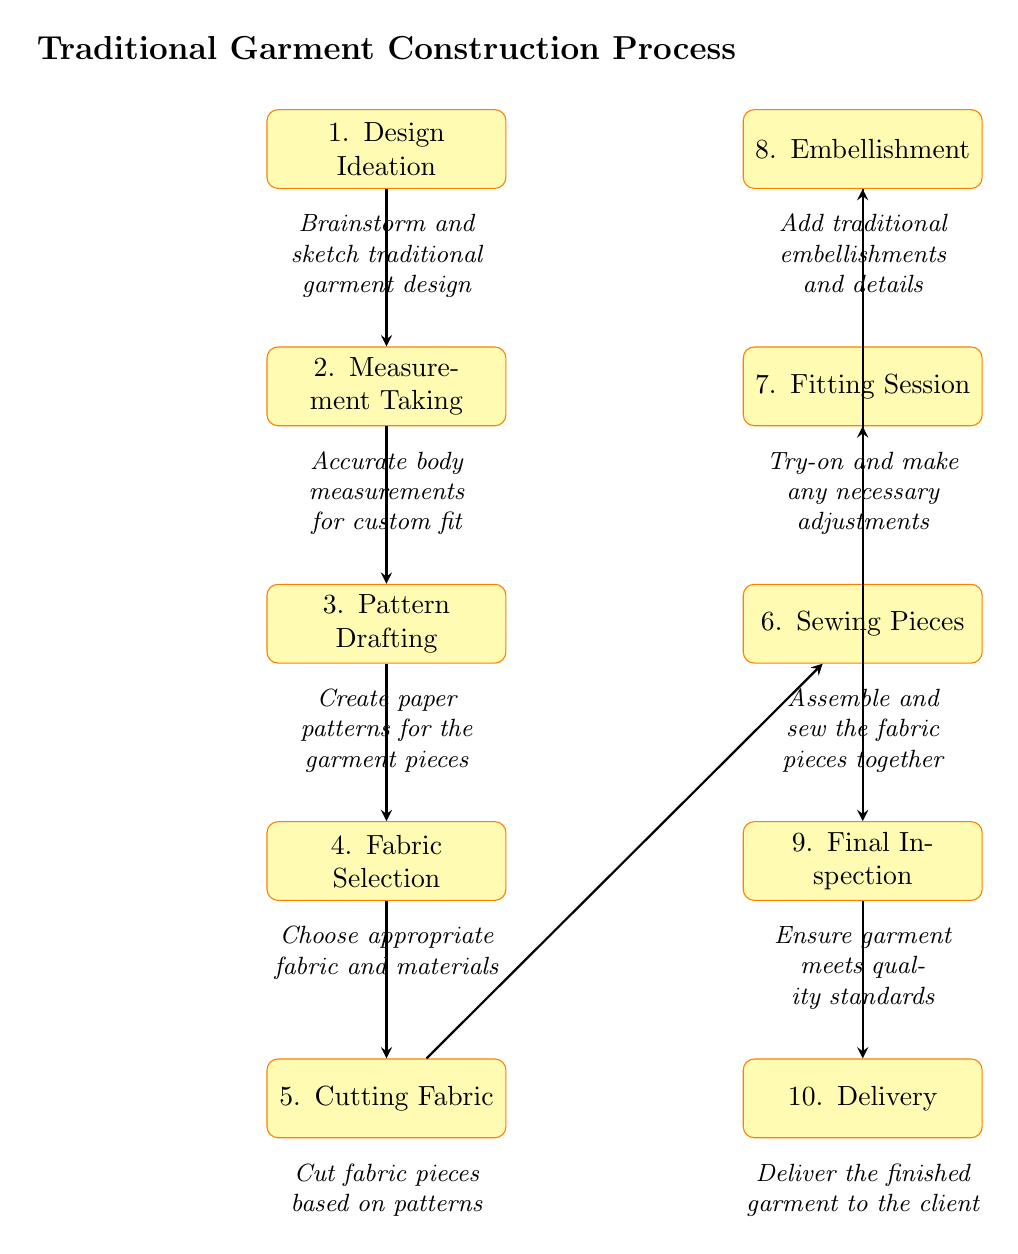What is the first step in the traditional garment construction process? The diagram lists "1. Design Ideation" as the first step, which is the initial stage of the process.
Answer: Design Ideation How many steps are listed in the traditional garment construction process? By counting the nodes in the diagram, we find a total of 10 steps involved in the garment construction process.
Answer: 10 What step comes after fabric selection? The diagram shows that after "4. Fabric Selection," the next step is "5. Cutting Fabric," connecting the two steps with an arrow.
Answer: Cutting Fabric Which step involves making adjustments? Referring to the diagram, "7. Fitting Session" is identified as the step where adjustments are made to ensure a proper fit.
Answer: Fitting Session What is the last step in the garment construction process? The final step is noted as "10. Delivery," which is the end point of the traditional garment construction process.
Answer: Delivery What is the main action taken in the sixth step? In the diagram, "6. Sewing Pieces" is described as the action of assembling and sewing the fabric pieces together.
Answer: Sewing Pieces Which two steps are directly connected by arrows in the diagram? Looking at the diagram, "3. Pattern Drafting" is connected to "4. Fabric Selection," indicating the flow from pattern creation to selecting fabric.
Answer: Pattern Drafting and Fabric Selection How does embellishment relate to the fitting session in the process? According to the diagram, "8. Embellishment" follows "7. Fitting Session," suggesting that embellishment happens after making the necessary adjustments.
Answer: Embellishment follows Fitting Session What is the significance of measurement taking in garment construction? "2. Measurement Taking" is crucial for ensuring a custom fit, as stated in the notes beside the node, highlighting its importance in the process.
Answer: Accurate body measurements for custom fit 